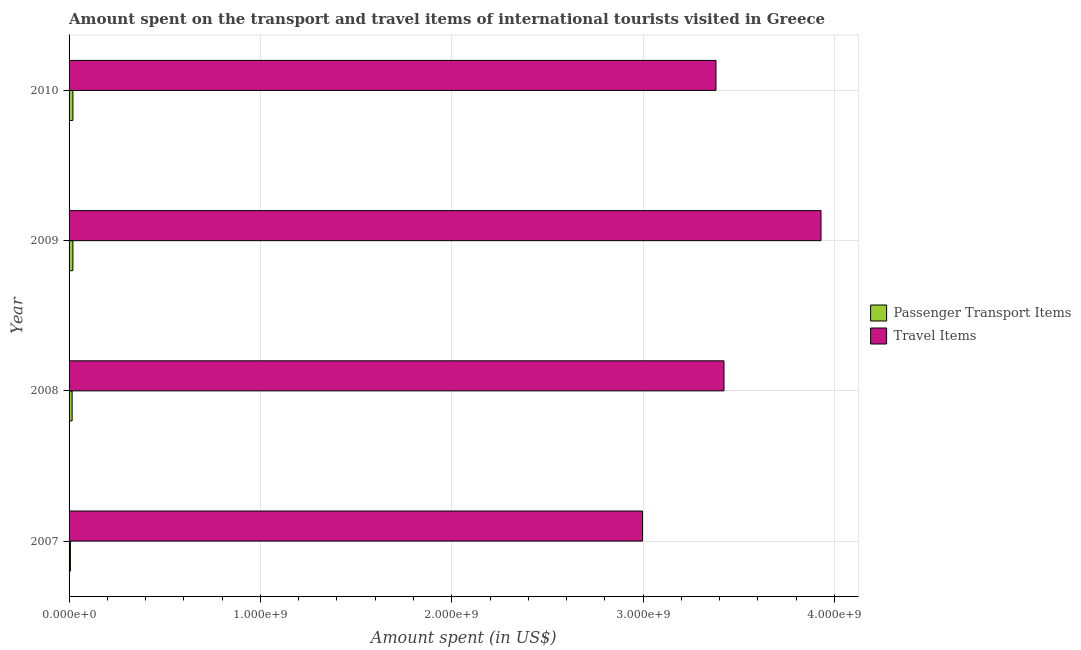Are the number of bars per tick equal to the number of legend labels?
Your answer should be compact. Yes. Are the number of bars on each tick of the Y-axis equal?
Provide a succinct answer. Yes. How many bars are there on the 4th tick from the top?
Your answer should be very brief. 2. How many bars are there on the 3rd tick from the bottom?
Offer a very short reply. 2. What is the label of the 3rd group of bars from the top?
Provide a succinct answer. 2008. What is the amount spent on passenger transport items in 2007?
Provide a short and direct response. 7.00e+06. Across all years, what is the maximum amount spent on passenger transport items?
Your answer should be compact. 2.00e+07. Across all years, what is the minimum amount spent on passenger transport items?
Make the answer very short. 7.00e+06. In which year was the amount spent on passenger transport items maximum?
Your answer should be compact. 2009. In which year was the amount spent on passenger transport items minimum?
Offer a very short reply. 2007. What is the total amount spent in travel items in the graph?
Provide a short and direct response. 1.37e+1. What is the difference between the amount spent on passenger transport items in 2007 and that in 2008?
Provide a succinct answer. -9.00e+06. What is the difference between the amount spent in travel items in 2009 and the amount spent on passenger transport items in 2007?
Ensure brevity in your answer.  3.92e+09. What is the average amount spent on passenger transport items per year?
Ensure brevity in your answer.  1.58e+07. In the year 2008, what is the difference between the amount spent in travel items and amount spent on passenger transport items?
Offer a very short reply. 3.41e+09. What is the ratio of the amount spent in travel items in 2007 to that in 2008?
Offer a very short reply. 0.88. What is the difference between the highest and the second highest amount spent in travel items?
Provide a succinct answer. 5.07e+08. What is the difference between the highest and the lowest amount spent on passenger transport items?
Ensure brevity in your answer.  1.30e+07. In how many years, is the amount spent in travel items greater than the average amount spent in travel items taken over all years?
Provide a succinct answer. 1. Is the sum of the amount spent in travel items in 2009 and 2010 greater than the maximum amount spent on passenger transport items across all years?
Your response must be concise. Yes. What does the 1st bar from the top in 2008 represents?
Your answer should be very brief. Travel Items. What does the 1st bar from the bottom in 2007 represents?
Your answer should be very brief. Passenger Transport Items. Are all the bars in the graph horizontal?
Make the answer very short. Yes. Are the values on the major ticks of X-axis written in scientific E-notation?
Make the answer very short. Yes. Does the graph contain any zero values?
Your answer should be compact. No. Where does the legend appear in the graph?
Provide a short and direct response. Center right. What is the title of the graph?
Provide a short and direct response. Amount spent on the transport and travel items of international tourists visited in Greece. What is the label or title of the X-axis?
Provide a short and direct response. Amount spent (in US$). What is the Amount spent (in US$) in Travel Items in 2007?
Offer a terse response. 3.00e+09. What is the Amount spent (in US$) in Passenger Transport Items in 2008?
Your response must be concise. 1.60e+07. What is the Amount spent (in US$) of Travel Items in 2008?
Make the answer very short. 3.42e+09. What is the Amount spent (in US$) of Passenger Transport Items in 2009?
Offer a terse response. 2.00e+07. What is the Amount spent (in US$) in Travel Items in 2009?
Provide a succinct answer. 3.93e+09. What is the Amount spent (in US$) of Travel Items in 2010?
Your answer should be very brief. 3.38e+09. Across all years, what is the maximum Amount spent (in US$) in Travel Items?
Your answer should be compact. 3.93e+09. Across all years, what is the minimum Amount spent (in US$) in Travel Items?
Provide a short and direct response. 3.00e+09. What is the total Amount spent (in US$) of Passenger Transport Items in the graph?
Keep it short and to the point. 6.30e+07. What is the total Amount spent (in US$) of Travel Items in the graph?
Give a very brief answer. 1.37e+1. What is the difference between the Amount spent (in US$) in Passenger Transport Items in 2007 and that in 2008?
Keep it short and to the point. -9.00e+06. What is the difference between the Amount spent (in US$) in Travel Items in 2007 and that in 2008?
Ensure brevity in your answer.  -4.26e+08. What is the difference between the Amount spent (in US$) of Passenger Transport Items in 2007 and that in 2009?
Keep it short and to the point. -1.30e+07. What is the difference between the Amount spent (in US$) of Travel Items in 2007 and that in 2009?
Offer a very short reply. -9.33e+08. What is the difference between the Amount spent (in US$) in Passenger Transport Items in 2007 and that in 2010?
Offer a very short reply. -1.30e+07. What is the difference between the Amount spent (in US$) in Travel Items in 2007 and that in 2010?
Keep it short and to the point. -3.84e+08. What is the difference between the Amount spent (in US$) in Travel Items in 2008 and that in 2009?
Keep it short and to the point. -5.07e+08. What is the difference between the Amount spent (in US$) in Passenger Transport Items in 2008 and that in 2010?
Offer a terse response. -4.00e+06. What is the difference between the Amount spent (in US$) in Travel Items in 2008 and that in 2010?
Provide a succinct answer. 4.20e+07. What is the difference between the Amount spent (in US$) in Passenger Transport Items in 2009 and that in 2010?
Provide a short and direct response. 0. What is the difference between the Amount spent (in US$) of Travel Items in 2009 and that in 2010?
Keep it short and to the point. 5.49e+08. What is the difference between the Amount spent (in US$) in Passenger Transport Items in 2007 and the Amount spent (in US$) in Travel Items in 2008?
Your answer should be very brief. -3.42e+09. What is the difference between the Amount spent (in US$) in Passenger Transport Items in 2007 and the Amount spent (in US$) in Travel Items in 2009?
Your response must be concise. -3.92e+09. What is the difference between the Amount spent (in US$) of Passenger Transport Items in 2007 and the Amount spent (in US$) of Travel Items in 2010?
Your response must be concise. -3.37e+09. What is the difference between the Amount spent (in US$) in Passenger Transport Items in 2008 and the Amount spent (in US$) in Travel Items in 2009?
Ensure brevity in your answer.  -3.91e+09. What is the difference between the Amount spent (in US$) in Passenger Transport Items in 2008 and the Amount spent (in US$) in Travel Items in 2010?
Your answer should be very brief. -3.36e+09. What is the difference between the Amount spent (in US$) in Passenger Transport Items in 2009 and the Amount spent (in US$) in Travel Items in 2010?
Provide a succinct answer. -3.36e+09. What is the average Amount spent (in US$) in Passenger Transport Items per year?
Make the answer very short. 1.58e+07. What is the average Amount spent (in US$) of Travel Items per year?
Your answer should be very brief. 3.43e+09. In the year 2007, what is the difference between the Amount spent (in US$) in Passenger Transport Items and Amount spent (in US$) in Travel Items?
Your response must be concise. -2.99e+09. In the year 2008, what is the difference between the Amount spent (in US$) in Passenger Transport Items and Amount spent (in US$) in Travel Items?
Your response must be concise. -3.41e+09. In the year 2009, what is the difference between the Amount spent (in US$) of Passenger Transport Items and Amount spent (in US$) of Travel Items?
Your answer should be compact. -3.91e+09. In the year 2010, what is the difference between the Amount spent (in US$) in Passenger Transport Items and Amount spent (in US$) in Travel Items?
Make the answer very short. -3.36e+09. What is the ratio of the Amount spent (in US$) in Passenger Transport Items in 2007 to that in 2008?
Offer a very short reply. 0.44. What is the ratio of the Amount spent (in US$) in Travel Items in 2007 to that in 2008?
Make the answer very short. 0.88. What is the ratio of the Amount spent (in US$) of Travel Items in 2007 to that in 2009?
Make the answer very short. 0.76. What is the ratio of the Amount spent (in US$) in Travel Items in 2007 to that in 2010?
Your answer should be compact. 0.89. What is the ratio of the Amount spent (in US$) of Passenger Transport Items in 2008 to that in 2009?
Provide a succinct answer. 0.8. What is the ratio of the Amount spent (in US$) of Travel Items in 2008 to that in 2009?
Make the answer very short. 0.87. What is the ratio of the Amount spent (in US$) of Passenger Transport Items in 2008 to that in 2010?
Your answer should be compact. 0.8. What is the ratio of the Amount spent (in US$) in Travel Items in 2008 to that in 2010?
Your response must be concise. 1.01. What is the ratio of the Amount spent (in US$) of Travel Items in 2009 to that in 2010?
Provide a succinct answer. 1.16. What is the difference between the highest and the second highest Amount spent (in US$) in Passenger Transport Items?
Offer a terse response. 0. What is the difference between the highest and the second highest Amount spent (in US$) of Travel Items?
Offer a very short reply. 5.07e+08. What is the difference between the highest and the lowest Amount spent (in US$) of Passenger Transport Items?
Provide a short and direct response. 1.30e+07. What is the difference between the highest and the lowest Amount spent (in US$) in Travel Items?
Ensure brevity in your answer.  9.33e+08. 